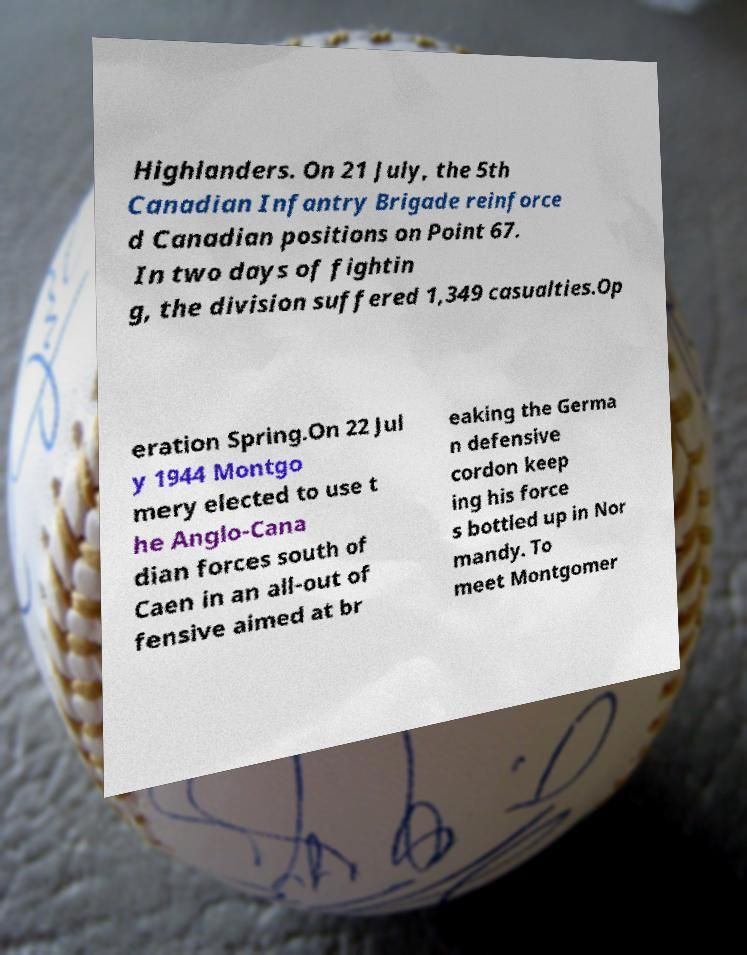I need the written content from this picture converted into text. Can you do that? Highlanders. On 21 July, the 5th Canadian Infantry Brigade reinforce d Canadian positions on Point 67. In two days of fightin g, the division suffered 1,349 casualties.Op eration Spring.On 22 Jul y 1944 Montgo mery elected to use t he Anglo-Cana dian forces south of Caen in an all-out of fensive aimed at br eaking the Germa n defensive cordon keep ing his force s bottled up in Nor mandy. To meet Montgomer 